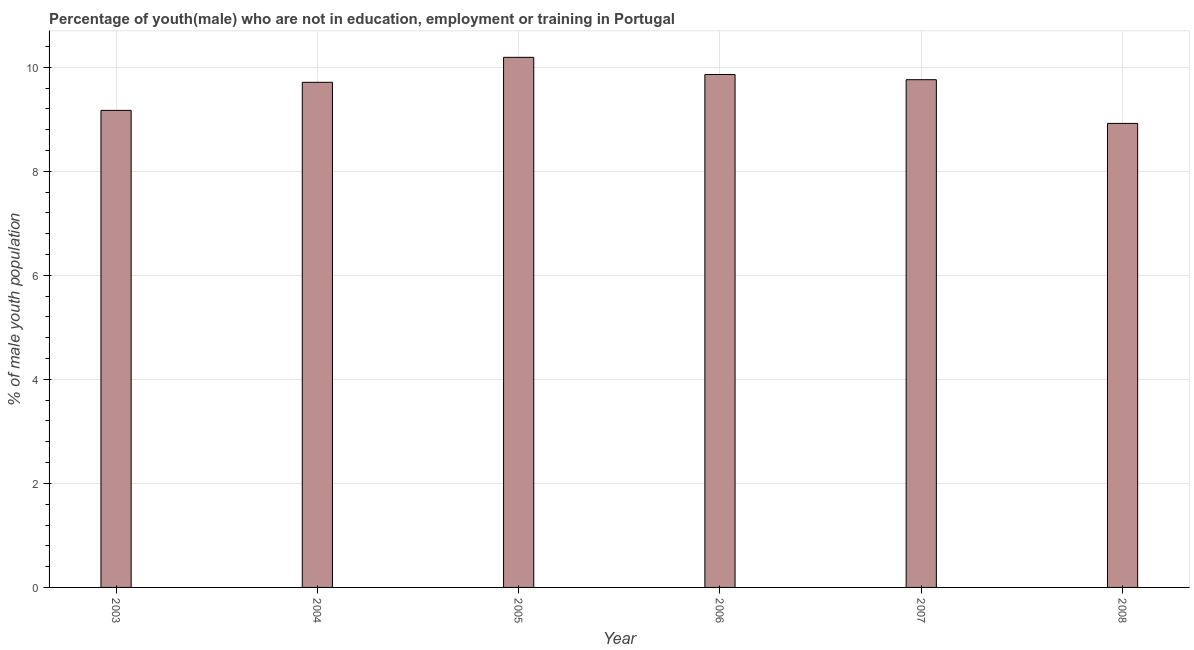Does the graph contain any zero values?
Your answer should be compact. No. Does the graph contain grids?
Your answer should be compact. Yes. What is the title of the graph?
Offer a terse response. Percentage of youth(male) who are not in education, employment or training in Portugal. What is the label or title of the Y-axis?
Give a very brief answer. % of male youth population. What is the unemployed male youth population in 2005?
Keep it short and to the point. 10.19. Across all years, what is the maximum unemployed male youth population?
Offer a very short reply. 10.19. Across all years, what is the minimum unemployed male youth population?
Offer a very short reply. 8.92. In which year was the unemployed male youth population minimum?
Your answer should be very brief. 2008. What is the sum of the unemployed male youth population?
Keep it short and to the point. 57.61. What is the difference between the unemployed male youth population in 2005 and 2007?
Provide a short and direct response. 0.43. What is the average unemployed male youth population per year?
Your answer should be compact. 9.6. What is the median unemployed male youth population?
Your answer should be very brief. 9.74. Do a majority of the years between 2003 and 2007 (inclusive) have unemployed male youth population greater than 3.2 %?
Provide a short and direct response. Yes. What is the ratio of the unemployed male youth population in 2003 to that in 2006?
Offer a very short reply. 0.93. Is the unemployed male youth population in 2005 less than that in 2008?
Your answer should be very brief. No. Is the difference between the unemployed male youth population in 2003 and 2007 greater than the difference between any two years?
Your response must be concise. No. What is the difference between the highest and the second highest unemployed male youth population?
Keep it short and to the point. 0.33. What is the difference between the highest and the lowest unemployed male youth population?
Offer a very short reply. 1.27. Are all the bars in the graph horizontal?
Provide a succinct answer. No. What is the difference between two consecutive major ticks on the Y-axis?
Your answer should be compact. 2. What is the % of male youth population in 2003?
Ensure brevity in your answer.  9.17. What is the % of male youth population of 2004?
Offer a very short reply. 9.71. What is the % of male youth population of 2005?
Offer a terse response. 10.19. What is the % of male youth population of 2006?
Keep it short and to the point. 9.86. What is the % of male youth population of 2007?
Provide a succinct answer. 9.76. What is the % of male youth population in 2008?
Make the answer very short. 8.92. What is the difference between the % of male youth population in 2003 and 2004?
Offer a terse response. -0.54. What is the difference between the % of male youth population in 2003 and 2005?
Give a very brief answer. -1.02. What is the difference between the % of male youth population in 2003 and 2006?
Your answer should be very brief. -0.69. What is the difference between the % of male youth population in 2003 and 2007?
Provide a succinct answer. -0.59. What is the difference between the % of male youth population in 2003 and 2008?
Your answer should be very brief. 0.25. What is the difference between the % of male youth population in 2004 and 2005?
Make the answer very short. -0.48. What is the difference between the % of male youth population in 2004 and 2006?
Ensure brevity in your answer.  -0.15. What is the difference between the % of male youth population in 2004 and 2008?
Make the answer very short. 0.79. What is the difference between the % of male youth population in 2005 and 2006?
Provide a short and direct response. 0.33. What is the difference between the % of male youth population in 2005 and 2007?
Make the answer very short. 0.43. What is the difference between the % of male youth population in 2005 and 2008?
Provide a succinct answer. 1.27. What is the difference between the % of male youth population in 2006 and 2007?
Provide a short and direct response. 0.1. What is the difference between the % of male youth population in 2006 and 2008?
Give a very brief answer. 0.94. What is the difference between the % of male youth population in 2007 and 2008?
Offer a terse response. 0.84. What is the ratio of the % of male youth population in 2003 to that in 2004?
Provide a short and direct response. 0.94. What is the ratio of the % of male youth population in 2003 to that in 2005?
Ensure brevity in your answer.  0.9. What is the ratio of the % of male youth population in 2003 to that in 2007?
Give a very brief answer. 0.94. What is the ratio of the % of male youth population in 2003 to that in 2008?
Give a very brief answer. 1.03. What is the ratio of the % of male youth population in 2004 to that in 2005?
Ensure brevity in your answer.  0.95. What is the ratio of the % of male youth population in 2004 to that in 2008?
Provide a succinct answer. 1.09. What is the ratio of the % of male youth population in 2005 to that in 2006?
Offer a terse response. 1.03. What is the ratio of the % of male youth population in 2005 to that in 2007?
Your answer should be very brief. 1.04. What is the ratio of the % of male youth population in 2005 to that in 2008?
Make the answer very short. 1.14. What is the ratio of the % of male youth population in 2006 to that in 2008?
Offer a terse response. 1.1. What is the ratio of the % of male youth population in 2007 to that in 2008?
Your answer should be very brief. 1.09. 